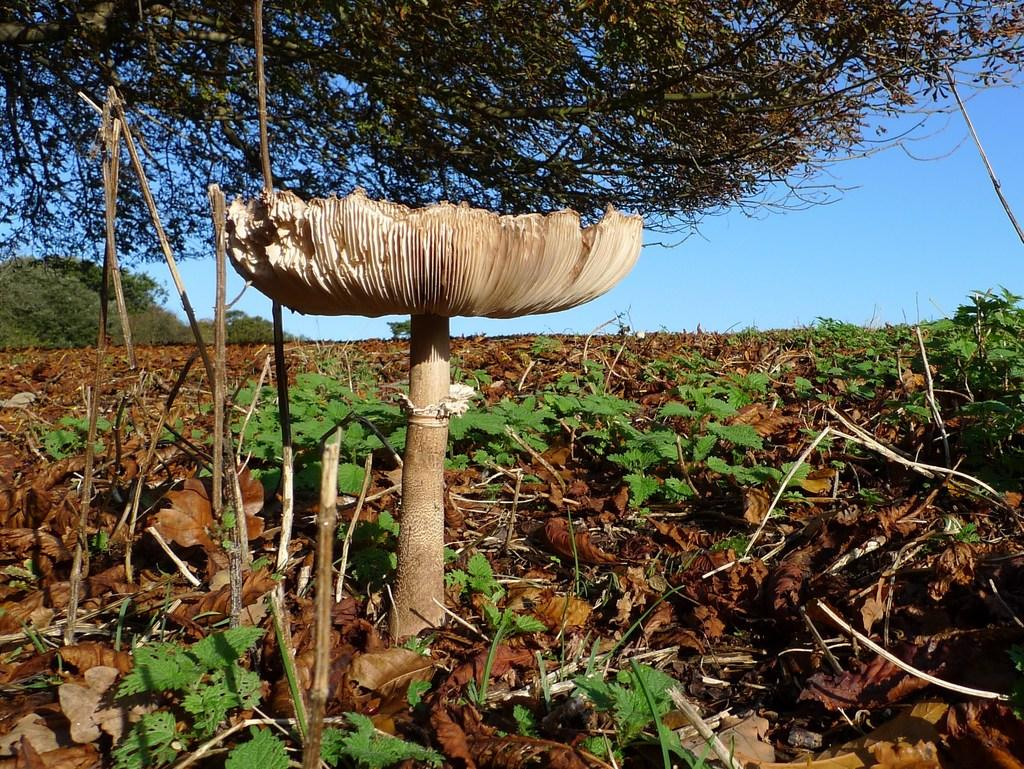What type of fungi can be seen in the image? There is a mushroom in the image. What other types of vegetation are present in the image? There are plants and trees in the image. What time of day is it at the school depicted in the image? There is no school present in the image, and therefore no indication of the time of day. Can you describe the squirrel's behavior in the image? There is no squirrel present in the image. 